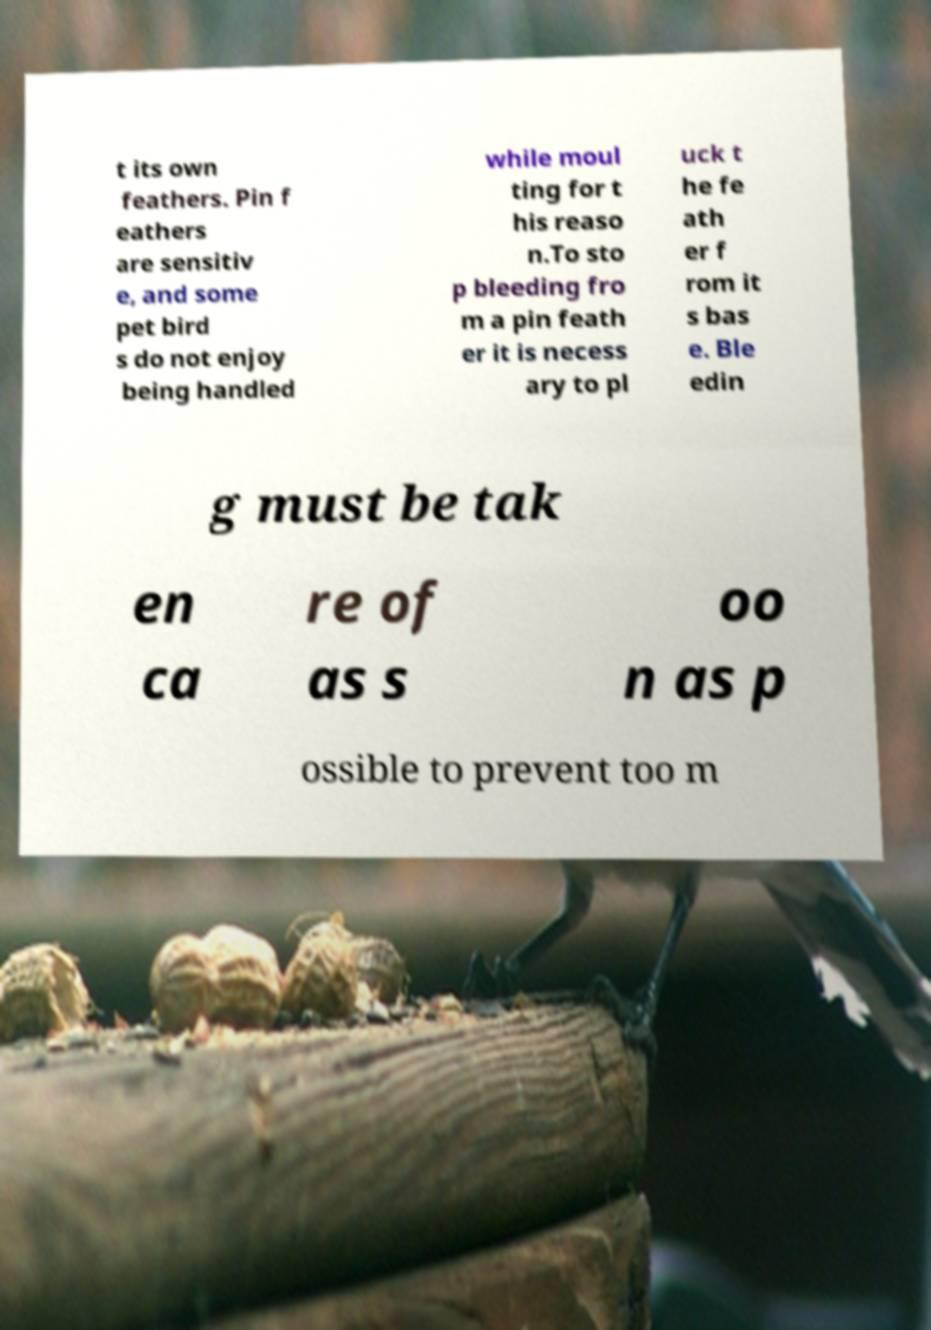Please read and relay the text visible in this image. What does it say? t its own feathers. Pin f eathers are sensitiv e, and some pet bird s do not enjoy being handled while moul ting for t his reaso n.To sto p bleeding fro m a pin feath er it is necess ary to pl uck t he fe ath er f rom it s bas e. Ble edin g must be tak en ca re of as s oo n as p ossible to prevent too m 